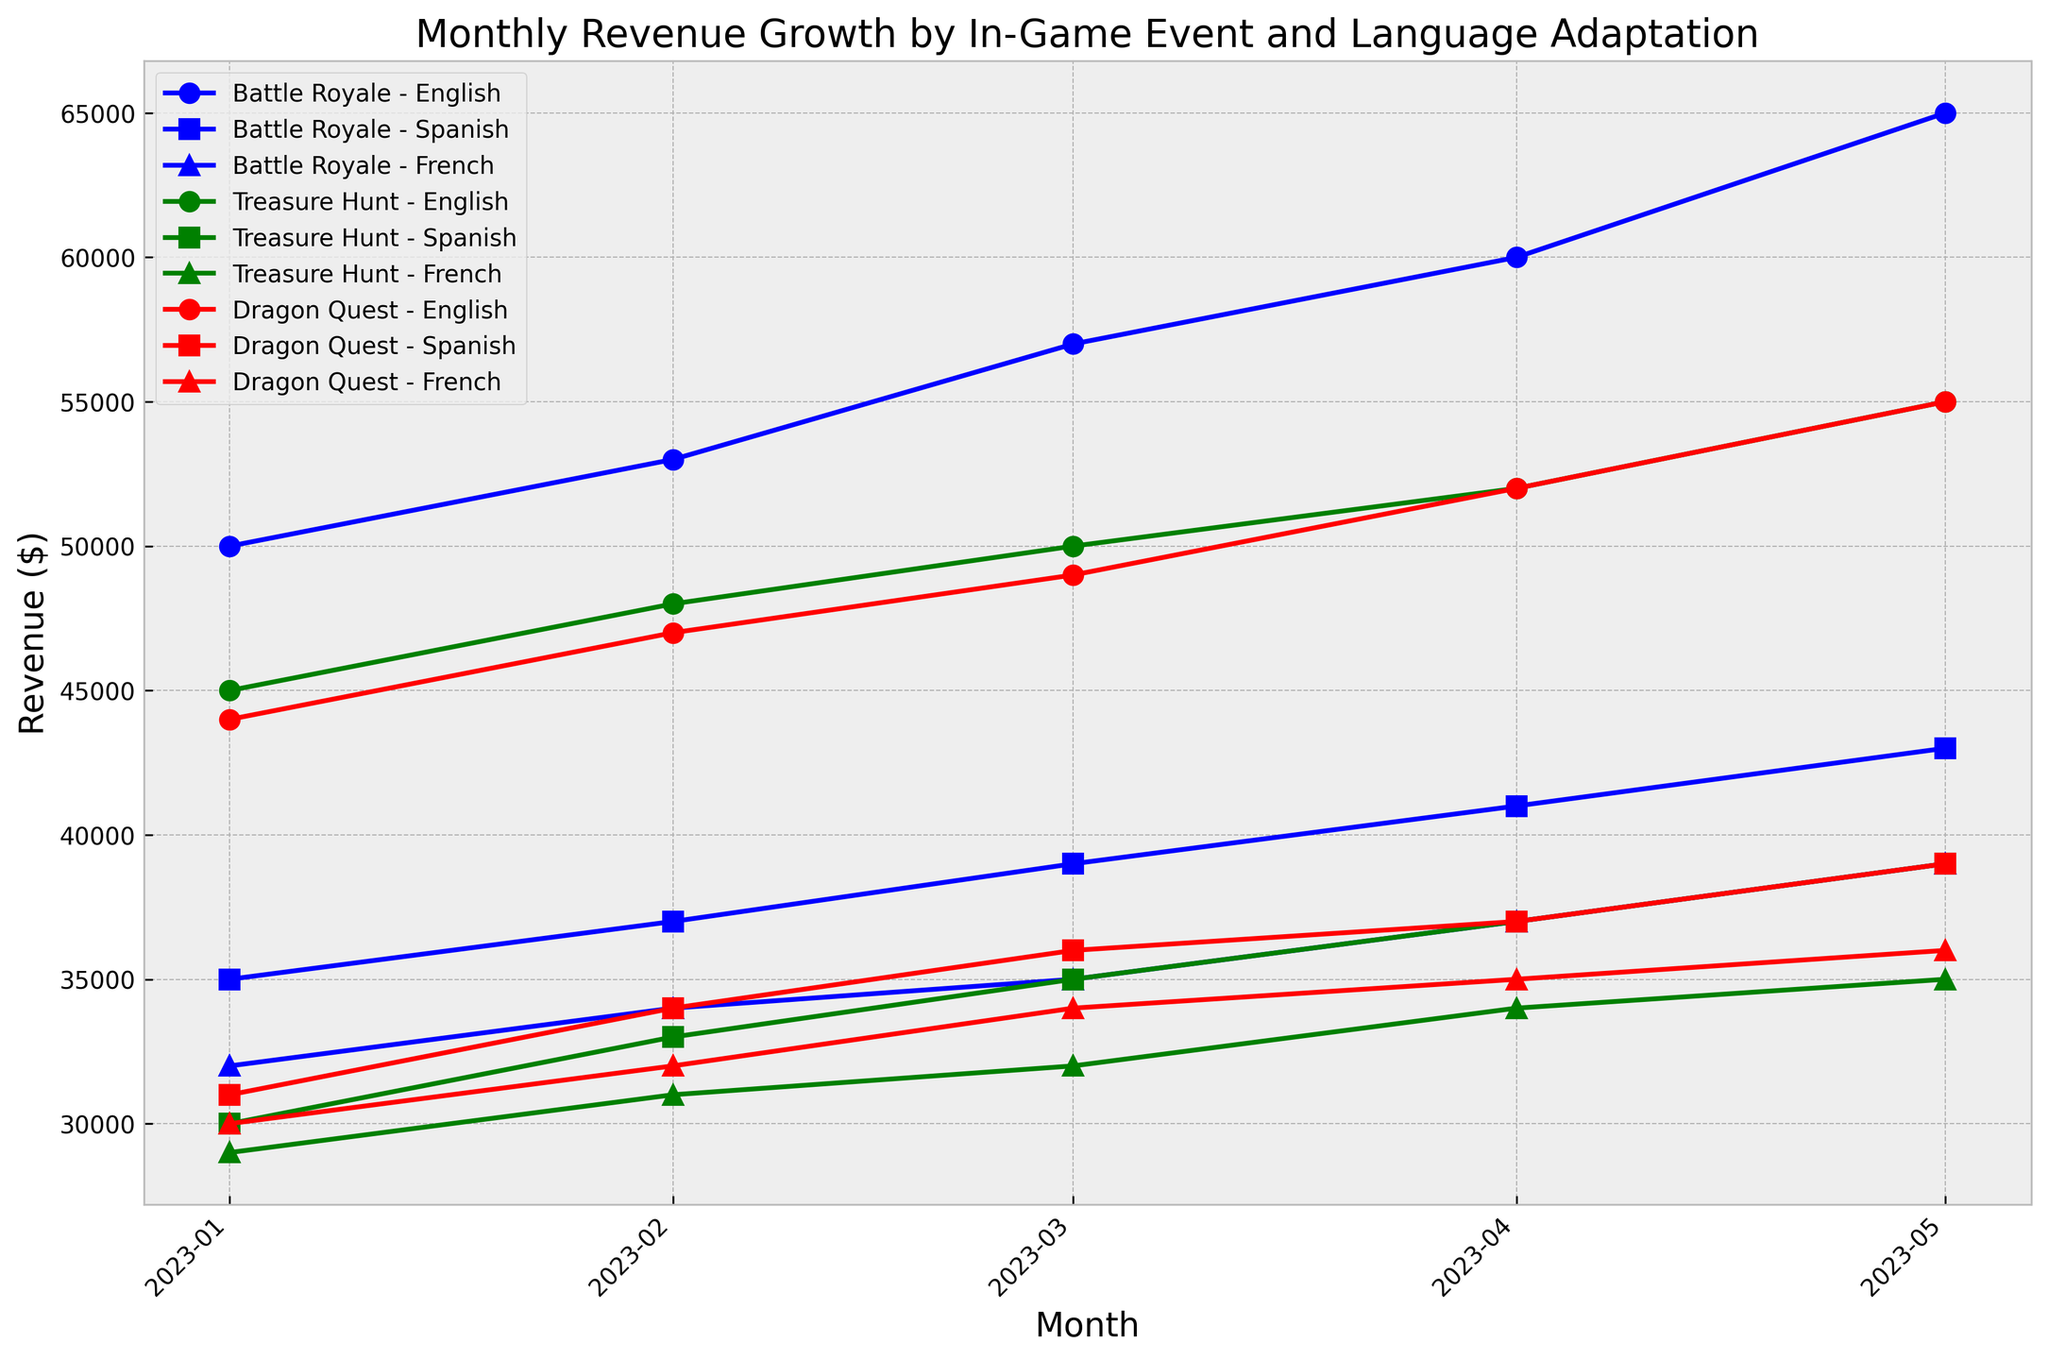What is the revenue trend for the "Battle Royale" event in English from January to May 2023? Look at the blue line with circle markers for the "Battle Royale - English" series. Starting from January with $50,000, it increases to $53,000 in February, $57,000 in March, $60,000 in April, and $65,000 in May.
Answer: Increasing Which event and language combination had the highest revenue in May 2023? Scan the revenue points for May 2023 across all event and language combinations. "Battle Royale - English" in May has the highest value of $65,000.
Answer: Battle Royale - English What is the total revenue for "Treasure Hunt" in French from January to May 2023? Add the revenue values for "Treasure Hunt - French" from January ($29,000), February ($31,000), March ($32,000), April ($34,000), and May ($35,000). The sum is $29,000 + $31,000 + $32,000 + $34,000 + $35,000 = $161,000.
Answer: $161,000 Which event shows the least overall revenue growth for Spanish players between January and May 2023? Compare the starting and ending revenue values for Spanish players of different events. For "Dragon Quest," revenue starts at $31,000 in January and ends at $39,000 in May, showing the smallest growth which is $39,000 - $31,000 = $8,000.
Answer: Dragon Quest Between "Treasure Hunt" and "Dragon Quest," which event had a higher average monthly revenue in French from January to May 2023? Calculate the average revenue for each event in French. "Treasure Hunt - French": (29,000 + 31,000 + 32,000 + 34,000 + 35,000) / 5 = $32,200. "Dragon Quest - French": (30,000 + 32,000 + 34,000 + 35,000 + 36,000) / 5 = $33,400. "Dragon Quest - French" has the higher average monthly revenue.
Answer: Dragon Quest Which language showed the most consistent revenue for the "Battle Royale" event from January to May 2023? Examine the revenue values for each language in the "Battle Royale" event from January to May. The English language shows a steady increment: $50,000, $53,000, $57,000, $60,000, and $65,000, which indicates the most consistent revenue growth.
Answer: English How much did the revenue for the "Treasure Hunt" event in Spanish increase from March to April 2023? Identify the revenue for "Treasure Hunt - Spanish" in March ($35,000) and April ($37,000). Calculate the difference: $37,000 - $35,000 = $2,000.
Answer: $2,000 